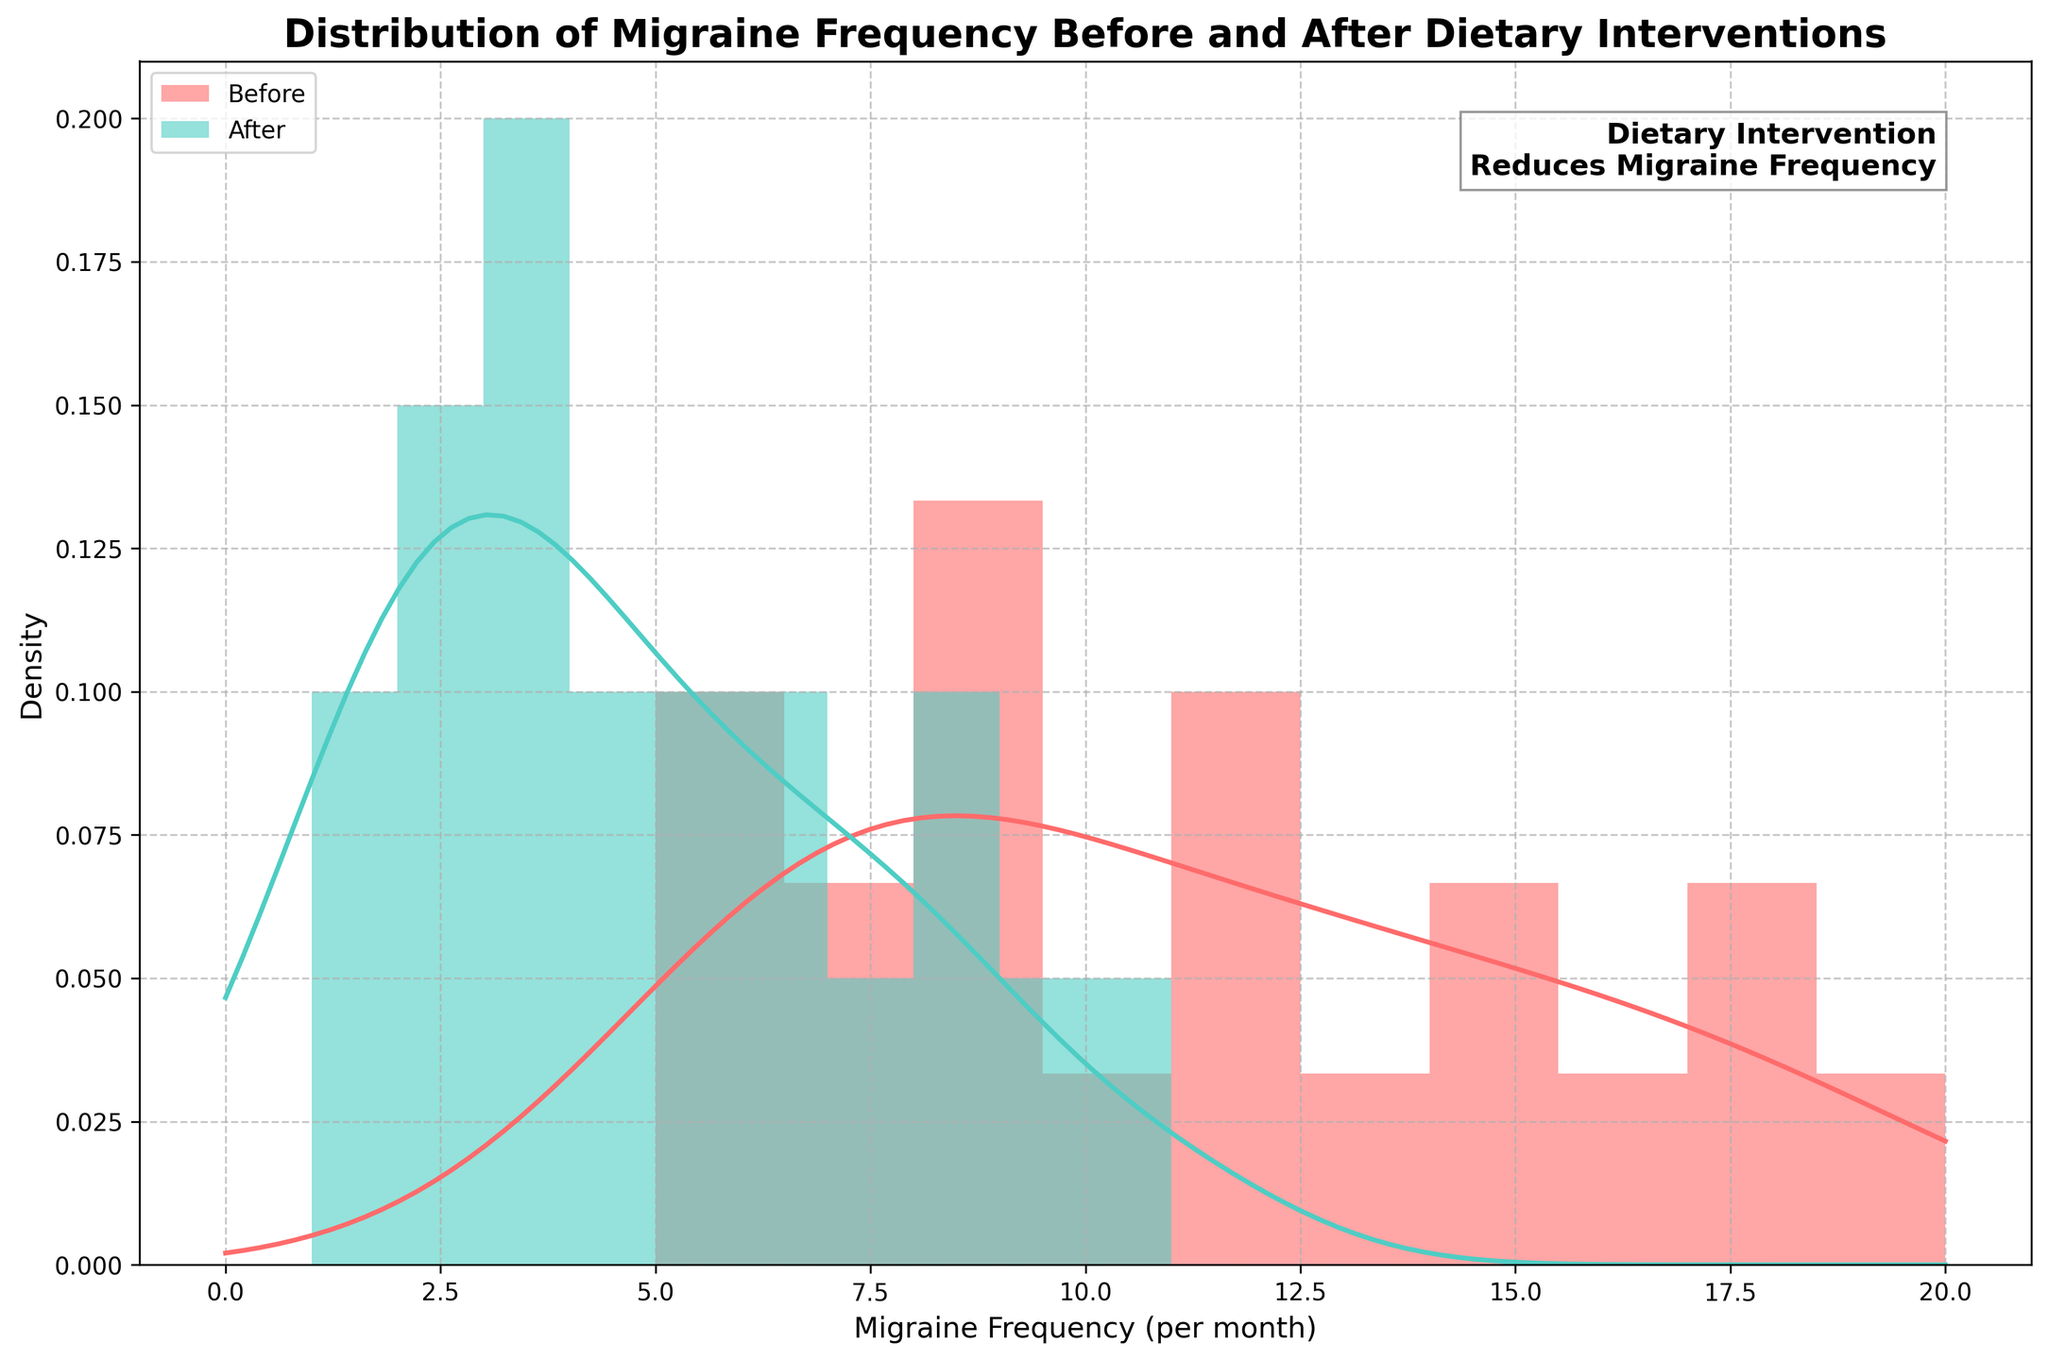What is the title of the figure? The title is found at the top of the plot and is formatted in bold text. It provides a summary of what the plot represents.
Answer: Distribution of Migraine Frequency Before and After Dietary Interventions What are the x-axis and y-axis labels? The x-axis label indicates the measurement along the horizontal axis, and the y-axis label indicates the measurement along the vertical axis. These provide context for the data being displayed.
Answer: The x-axis label is "Migraine Frequency (per month)", and the y-axis label is "Density" What do the colors red and green represent in the figure? The colors are associated with different datasets, supported by the legend embedded within the plot.
Answer: Red represents 'Before' dietary intervention, and green represents 'After' dietary intervention What appears to be the maximum migraine frequency observed before and after the dietary intervention? By examining the KDE curves and histograms, we can determine the approximate maximum values along the x-axis for each curve.
Answer: Around 20 before and 11 after How do the shapes of the KDE curves differ before and after the dietary intervention? The shapes of the KDE curves represent the distribution of migraine frequencies. Comparing these shapes involves noting the peaks and spreads of the curves.
Answer: The 'Before' curve has a higher peak around 10-13 migraines, while the 'After' curve peaks at a lower frequency around 3-5 migraines From the histograms, what can you infer about the density of lower migraine frequencies (e.g., 0-5) before and after the dietary intervention? Histograms show the distribution of data points, and comparing the heights of bars in the 0-5 range allows us to infer densities.
Answer: There is a higher density of lower migraine frequencies (0-5) after the dietary intervention compared to before What does the text annotation in the upper-right corner of the plot indicate? The text annotation provides an insight or highlights an important finding directly related to the visual context of the plot.
Answer: It indicates that "Dietary Intervention Reduces Migraine Frequency" How does the variation in migraine frequency change after the dietary intervention compared to before? Variation can be determined by the spread of the KDE curves and the width of the histogram bars. A wider spread indicates more variation.
Answer: The variation appears to decrease after the dietary intervention, as the 'After' KDE curve is more narrow and peaked compared to the 'Before' curve Based on the KDE curves, which intervention status shows a greater density of migraine frequencies around 5-10 migraines per month? Comparing the KDE curves, we can see which curve is higher in the 5-10 frequency range.
Answer: The 'Before' dietary intervention shows a greater density around 5-10 migraines per month compared to the 'After' intervention How does the overall trend in migraine frequency distribution change from before to after the dietary intervention? This involves synthesizing the visual information from both histograms and KDE curves to deduce the broader pattern or trend.
Answer: The overall trend shows a decrease in higher migraine frequencies and an increase in lower migraine frequencies after the dietary intervention 